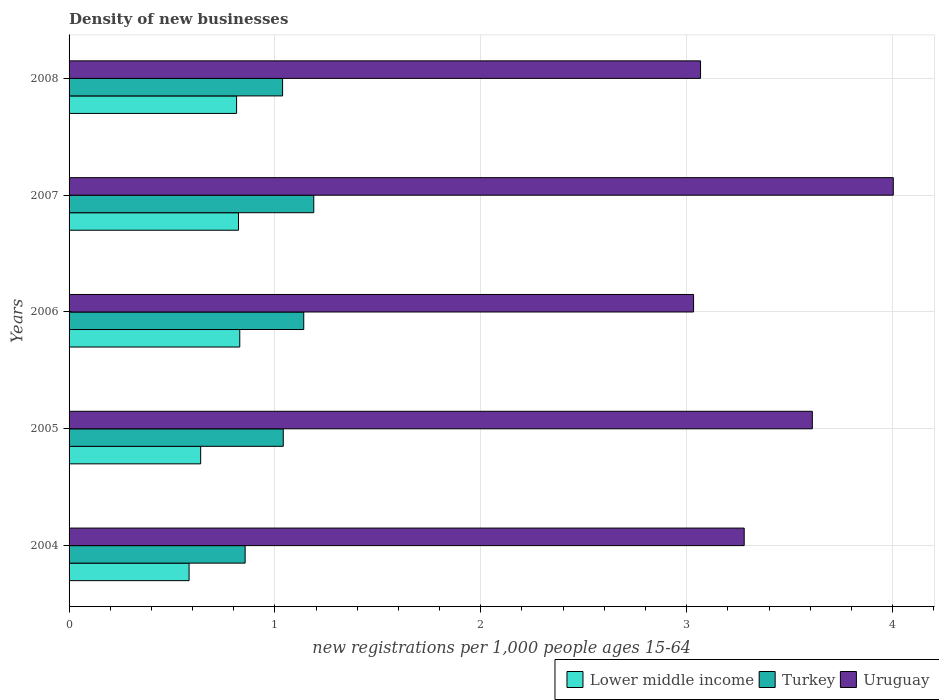How many groups of bars are there?
Your response must be concise. 5. Are the number of bars on each tick of the Y-axis equal?
Offer a very short reply. Yes. How many bars are there on the 4th tick from the top?
Ensure brevity in your answer.  3. What is the number of new registrations in Uruguay in 2004?
Provide a succinct answer. 3.28. Across all years, what is the maximum number of new registrations in Uruguay?
Give a very brief answer. 4. Across all years, what is the minimum number of new registrations in Lower middle income?
Make the answer very short. 0.58. In which year was the number of new registrations in Uruguay maximum?
Provide a short and direct response. 2007. In which year was the number of new registrations in Uruguay minimum?
Provide a succinct answer. 2006. What is the total number of new registrations in Turkey in the graph?
Make the answer very short. 5.26. What is the difference between the number of new registrations in Turkey in 2007 and that in 2008?
Make the answer very short. 0.15. What is the difference between the number of new registrations in Uruguay in 2008 and the number of new registrations in Lower middle income in 2007?
Provide a succinct answer. 2.24. What is the average number of new registrations in Uruguay per year?
Provide a succinct answer. 3.4. In the year 2007, what is the difference between the number of new registrations in Uruguay and number of new registrations in Turkey?
Make the answer very short. 2.82. What is the ratio of the number of new registrations in Lower middle income in 2004 to that in 2006?
Keep it short and to the point. 0.7. Is the number of new registrations in Uruguay in 2004 less than that in 2006?
Your answer should be very brief. No. What is the difference between the highest and the second highest number of new registrations in Uruguay?
Provide a short and direct response. 0.39. What is the difference between the highest and the lowest number of new registrations in Lower middle income?
Provide a succinct answer. 0.25. In how many years, is the number of new registrations in Uruguay greater than the average number of new registrations in Uruguay taken over all years?
Your answer should be very brief. 2. What does the 3rd bar from the bottom in 2004 represents?
Make the answer very short. Uruguay. How many bars are there?
Your answer should be compact. 15. Are all the bars in the graph horizontal?
Your response must be concise. Yes. How many years are there in the graph?
Your answer should be compact. 5. What is the difference between two consecutive major ticks on the X-axis?
Keep it short and to the point. 1. Does the graph contain any zero values?
Your response must be concise. No. How many legend labels are there?
Make the answer very short. 3. What is the title of the graph?
Provide a succinct answer. Density of new businesses. Does "Oman" appear as one of the legend labels in the graph?
Ensure brevity in your answer.  No. What is the label or title of the X-axis?
Make the answer very short. New registrations per 1,0 people ages 15-64. What is the label or title of the Y-axis?
Your answer should be compact. Years. What is the new registrations per 1,000 people ages 15-64 in Lower middle income in 2004?
Your answer should be compact. 0.58. What is the new registrations per 1,000 people ages 15-64 in Turkey in 2004?
Give a very brief answer. 0.86. What is the new registrations per 1,000 people ages 15-64 in Uruguay in 2004?
Keep it short and to the point. 3.28. What is the new registrations per 1,000 people ages 15-64 in Lower middle income in 2005?
Your answer should be very brief. 0.64. What is the new registrations per 1,000 people ages 15-64 in Turkey in 2005?
Provide a succinct answer. 1.04. What is the new registrations per 1,000 people ages 15-64 in Uruguay in 2005?
Your answer should be very brief. 3.61. What is the new registrations per 1,000 people ages 15-64 in Lower middle income in 2006?
Offer a terse response. 0.83. What is the new registrations per 1,000 people ages 15-64 in Turkey in 2006?
Provide a succinct answer. 1.14. What is the new registrations per 1,000 people ages 15-64 of Uruguay in 2006?
Your answer should be very brief. 3.03. What is the new registrations per 1,000 people ages 15-64 of Lower middle income in 2007?
Provide a short and direct response. 0.82. What is the new registrations per 1,000 people ages 15-64 in Turkey in 2007?
Your answer should be compact. 1.19. What is the new registrations per 1,000 people ages 15-64 of Uruguay in 2007?
Offer a very short reply. 4. What is the new registrations per 1,000 people ages 15-64 in Lower middle income in 2008?
Keep it short and to the point. 0.81. What is the new registrations per 1,000 people ages 15-64 of Turkey in 2008?
Provide a short and direct response. 1.04. What is the new registrations per 1,000 people ages 15-64 in Uruguay in 2008?
Ensure brevity in your answer.  3.07. Across all years, what is the maximum new registrations per 1,000 people ages 15-64 of Lower middle income?
Offer a very short reply. 0.83. Across all years, what is the maximum new registrations per 1,000 people ages 15-64 in Turkey?
Keep it short and to the point. 1.19. Across all years, what is the maximum new registrations per 1,000 people ages 15-64 in Uruguay?
Keep it short and to the point. 4. Across all years, what is the minimum new registrations per 1,000 people ages 15-64 of Lower middle income?
Your answer should be very brief. 0.58. Across all years, what is the minimum new registrations per 1,000 people ages 15-64 of Turkey?
Offer a terse response. 0.86. Across all years, what is the minimum new registrations per 1,000 people ages 15-64 in Uruguay?
Offer a terse response. 3.03. What is the total new registrations per 1,000 people ages 15-64 of Lower middle income in the graph?
Your answer should be compact. 3.69. What is the total new registrations per 1,000 people ages 15-64 in Turkey in the graph?
Ensure brevity in your answer.  5.26. What is the total new registrations per 1,000 people ages 15-64 in Uruguay in the graph?
Provide a succinct answer. 16.99. What is the difference between the new registrations per 1,000 people ages 15-64 of Lower middle income in 2004 and that in 2005?
Your response must be concise. -0.06. What is the difference between the new registrations per 1,000 people ages 15-64 of Turkey in 2004 and that in 2005?
Keep it short and to the point. -0.19. What is the difference between the new registrations per 1,000 people ages 15-64 in Uruguay in 2004 and that in 2005?
Your response must be concise. -0.33. What is the difference between the new registrations per 1,000 people ages 15-64 in Lower middle income in 2004 and that in 2006?
Offer a very short reply. -0.25. What is the difference between the new registrations per 1,000 people ages 15-64 in Turkey in 2004 and that in 2006?
Make the answer very short. -0.28. What is the difference between the new registrations per 1,000 people ages 15-64 of Uruguay in 2004 and that in 2006?
Make the answer very short. 0.25. What is the difference between the new registrations per 1,000 people ages 15-64 of Lower middle income in 2004 and that in 2007?
Offer a terse response. -0.24. What is the difference between the new registrations per 1,000 people ages 15-64 in Turkey in 2004 and that in 2007?
Provide a succinct answer. -0.33. What is the difference between the new registrations per 1,000 people ages 15-64 of Uruguay in 2004 and that in 2007?
Ensure brevity in your answer.  -0.72. What is the difference between the new registrations per 1,000 people ages 15-64 of Lower middle income in 2004 and that in 2008?
Provide a succinct answer. -0.23. What is the difference between the new registrations per 1,000 people ages 15-64 in Turkey in 2004 and that in 2008?
Offer a very short reply. -0.18. What is the difference between the new registrations per 1,000 people ages 15-64 in Uruguay in 2004 and that in 2008?
Your answer should be very brief. 0.21. What is the difference between the new registrations per 1,000 people ages 15-64 of Lower middle income in 2005 and that in 2006?
Provide a short and direct response. -0.19. What is the difference between the new registrations per 1,000 people ages 15-64 of Turkey in 2005 and that in 2006?
Provide a succinct answer. -0.1. What is the difference between the new registrations per 1,000 people ages 15-64 in Uruguay in 2005 and that in 2006?
Offer a terse response. 0.58. What is the difference between the new registrations per 1,000 people ages 15-64 of Lower middle income in 2005 and that in 2007?
Your answer should be compact. -0.18. What is the difference between the new registrations per 1,000 people ages 15-64 of Turkey in 2005 and that in 2007?
Give a very brief answer. -0.15. What is the difference between the new registrations per 1,000 people ages 15-64 of Uruguay in 2005 and that in 2007?
Your answer should be compact. -0.39. What is the difference between the new registrations per 1,000 people ages 15-64 in Lower middle income in 2005 and that in 2008?
Your response must be concise. -0.17. What is the difference between the new registrations per 1,000 people ages 15-64 of Turkey in 2005 and that in 2008?
Provide a short and direct response. 0. What is the difference between the new registrations per 1,000 people ages 15-64 in Uruguay in 2005 and that in 2008?
Your answer should be very brief. 0.54. What is the difference between the new registrations per 1,000 people ages 15-64 of Lower middle income in 2006 and that in 2007?
Provide a short and direct response. 0.01. What is the difference between the new registrations per 1,000 people ages 15-64 of Turkey in 2006 and that in 2007?
Provide a short and direct response. -0.05. What is the difference between the new registrations per 1,000 people ages 15-64 of Uruguay in 2006 and that in 2007?
Provide a short and direct response. -0.97. What is the difference between the new registrations per 1,000 people ages 15-64 of Lower middle income in 2006 and that in 2008?
Your answer should be compact. 0.02. What is the difference between the new registrations per 1,000 people ages 15-64 of Turkey in 2006 and that in 2008?
Your response must be concise. 0.1. What is the difference between the new registrations per 1,000 people ages 15-64 in Uruguay in 2006 and that in 2008?
Make the answer very short. -0.03. What is the difference between the new registrations per 1,000 people ages 15-64 of Lower middle income in 2007 and that in 2008?
Give a very brief answer. 0.01. What is the difference between the new registrations per 1,000 people ages 15-64 in Turkey in 2007 and that in 2008?
Your answer should be compact. 0.15. What is the difference between the new registrations per 1,000 people ages 15-64 in Uruguay in 2007 and that in 2008?
Offer a very short reply. 0.94. What is the difference between the new registrations per 1,000 people ages 15-64 of Lower middle income in 2004 and the new registrations per 1,000 people ages 15-64 of Turkey in 2005?
Provide a short and direct response. -0.46. What is the difference between the new registrations per 1,000 people ages 15-64 of Lower middle income in 2004 and the new registrations per 1,000 people ages 15-64 of Uruguay in 2005?
Make the answer very short. -3.03. What is the difference between the new registrations per 1,000 people ages 15-64 in Turkey in 2004 and the new registrations per 1,000 people ages 15-64 in Uruguay in 2005?
Provide a succinct answer. -2.76. What is the difference between the new registrations per 1,000 people ages 15-64 of Lower middle income in 2004 and the new registrations per 1,000 people ages 15-64 of Turkey in 2006?
Your response must be concise. -0.56. What is the difference between the new registrations per 1,000 people ages 15-64 of Lower middle income in 2004 and the new registrations per 1,000 people ages 15-64 of Uruguay in 2006?
Provide a short and direct response. -2.45. What is the difference between the new registrations per 1,000 people ages 15-64 in Turkey in 2004 and the new registrations per 1,000 people ages 15-64 in Uruguay in 2006?
Provide a succinct answer. -2.18. What is the difference between the new registrations per 1,000 people ages 15-64 of Lower middle income in 2004 and the new registrations per 1,000 people ages 15-64 of Turkey in 2007?
Keep it short and to the point. -0.61. What is the difference between the new registrations per 1,000 people ages 15-64 in Lower middle income in 2004 and the new registrations per 1,000 people ages 15-64 in Uruguay in 2007?
Give a very brief answer. -3.42. What is the difference between the new registrations per 1,000 people ages 15-64 of Turkey in 2004 and the new registrations per 1,000 people ages 15-64 of Uruguay in 2007?
Your answer should be compact. -3.15. What is the difference between the new registrations per 1,000 people ages 15-64 of Lower middle income in 2004 and the new registrations per 1,000 people ages 15-64 of Turkey in 2008?
Your answer should be compact. -0.45. What is the difference between the new registrations per 1,000 people ages 15-64 of Lower middle income in 2004 and the new registrations per 1,000 people ages 15-64 of Uruguay in 2008?
Make the answer very short. -2.48. What is the difference between the new registrations per 1,000 people ages 15-64 in Turkey in 2004 and the new registrations per 1,000 people ages 15-64 in Uruguay in 2008?
Give a very brief answer. -2.21. What is the difference between the new registrations per 1,000 people ages 15-64 in Lower middle income in 2005 and the new registrations per 1,000 people ages 15-64 in Turkey in 2006?
Make the answer very short. -0.5. What is the difference between the new registrations per 1,000 people ages 15-64 in Lower middle income in 2005 and the new registrations per 1,000 people ages 15-64 in Uruguay in 2006?
Your answer should be compact. -2.39. What is the difference between the new registrations per 1,000 people ages 15-64 in Turkey in 2005 and the new registrations per 1,000 people ages 15-64 in Uruguay in 2006?
Ensure brevity in your answer.  -1.99. What is the difference between the new registrations per 1,000 people ages 15-64 in Lower middle income in 2005 and the new registrations per 1,000 people ages 15-64 in Turkey in 2007?
Keep it short and to the point. -0.55. What is the difference between the new registrations per 1,000 people ages 15-64 of Lower middle income in 2005 and the new registrations per 1,000 people ages 15-64 of Uruguay in 2007?
Give a very brief answer. -3.36. What is the difference between the new registrations per 1,000 people ages 15-64 in Turkey in 2005 and the new registrations per 1,000 people ages 15-64 in Uruguay in 2007?
Offer a very short reply. -2.96. What is the difference between the new registrations per 1,000 people ages 15-64 of Lower middle income in 2005 and the new registrations per 1,000 people ages 15-64 of Turkey in 2008?
Give a very brief answer. -0.4. What is the difference between the new registrations per 1,000 people ages 15-64 in Lower middle income in 2005 and the new registrations per 1,000 people ages 15-64 in Uruguay in 2008?
Make the answer very short. -2.43. What is the difference between the new registrations per 1,000 people ages 15-64 in Turkey in 2005 and the new registrations per 1,000 people ages 15-64 in Uruguay in 2008?
Provide a short and direct response. -2.03. What is the difference between the new registrations per 1,000 people ages 15-64 of Lower middle income in 2006 and the new registrations per 1,000 people ages 15-64 of Turkey in 2007?
Keep it short and to the point. -0.36. What is the difference between the new registrations per 1,000 people ages 15-64 of Lower middle income in 2006 and the new registrations per 1,000 people ages 15-64 of Uruguay in 2007?
Keep it short and to the point. -3.17. What is the difference between the new registrations per 1,000 people ages 15-64 in Turkey in 2006 and the new registrations per 1,000 people ages 15-64 in Uruguay in 2007?
Offer a terse response. -2.86. What is the difference between the new registrations per 1,000 people ages 15-64 in Lower middle income in 2006 and the new registrations per 1,000 people ages 15-64 in Turkey in 2008?
Offer a very short reply. -0.21. What is the difference between the new registrations per 1,000 people ages 15-64 in Lower middle income in 2006 and the new registrations per 1,000 people ages 15-64 in Uruguay in 2008?
Ensure brevity in your answer.  -2.24. What is the difference between the new registrations per 1,000 people ages 15-64 in Turkey in 2006 and the new registrations per 1,000 people ages 15-64 in Uruguay in 2008?
Provide a short and direct response. -1.93. What is the difference between the new registrations per 1,000 people ages 15-64 of Lower middle income in 2007 and the new registrations per 1,000 people ages 15-64 of Turkey in 2008?
Your answer should be very brief. -0.21. What is the difference between the new registrations per 1,000 people ages 15-64 of Lower middle income in 2007 and the new registrations per 1,000 people ages 15-64 of Uruguay in 2008?
Provide a short and direct response. -2.24. What is the difference between the new registrations per 1,000 people ages 15-64 of Turkey in 2007 and the new registrations per 1,000 people ages 15-64 of Uruguay in 2008?
Keep it short and to the point. -1.88. What is the average new registrations per 1,000 people ages 15-64 of Lower middle income per year?
Ensure brevity in your answer.  0.74. What is the average new registrations per 1,000 people ages 15-64 of Turkey per year?
Your response must be concise. 1.05. What is the average new registrations per 1,000 people ages 15-64 of Uruguay per year?
Your response must be concise. 3.4. In the year 2004, what is the difference between the new registrations per 1,000 people ages 15-64 of Lower middle income and new registrations per 1,000 people ages 15-64 of Turkey?
Provide a succinct answer. -0.27. In the year 2004, what is the difference between the new registrations per 1,000 people ages 15-64 of Lower middle income and new registrations per 1,000 people ages 15-64 of Uruguay?
Provide a short and direct response. -2.7. In the year 2004, what is the difference between the new registrations per 1,000 people ages 15-64 of Turkey and new registrations per 1,000 people ages 15-64 of Uruguay?
Offer a very short reply. -2.42. In the year 2005, what is the difference between the new registrations per 1,000 people ages 15-64 in Lower middle income and new registrations per 1,000 people ages 15-64 in Turkey?
Provide a short and direct response. -0.4. In the year 2005, what is the difference between the new registrations per 1,000 people ages 15-64 in Lower middle income and new registrations per 1,000 people ages 15-64 in Uruguay?
Provide a short and direct response. -2.97. In the year 2005, what is the difference between the new registrations per 1,000 people ages 15-64 of Turkey and new registrations per 1,000 people ages 15-64 of Uruguay?
Your answer should be compact. -2.57. In the year 2006, what is the difference between the new registrations per 1,000 people ages 15-64 in Lower middle income and new registrations per 1,000 people ages 15-64 in Turkey?
Offer a very short reply. -0.31. In the year 2006, what is the difference between the new registrations per 1,000 people ages 15-64 in Lower middle income and new registrations per 1,000 people ages 15-64 in Uruguay?
Your answer should be very brief. -2.2. In the year 2006, what is the difference between the new registrations per 1,000 people ages 15-64 of Turkey and new registrations per 1,000 people ages 15-64 of Uruguay?
Provide a succinct answer. -1.89. In the year 2007, what is the difference between the new registrations per 1,000 people ages 15-64 in Lower middle income and new registrations per 1,000 people ages 15-64 in Turkey?
Offer a very short reply. -0.37. In the year 2007, what is the difference between the new registrations per 1,000 people ages 15-64 of Lower middle income and new registrations per 1,000 people ages 15-64 of Uruguay?
Your answer should be very brief. -3.18. In the year 2007, what is the difference between the new registrations per 1,000 people ages 15-64 of Turkey and new registrations per 1,000 people ages 15-64 of Uruguay?
Offer a very short reply. -2.81. In the year 2008, what is the difference between the new registrations per 1,000 people ages 15-64 in Lower middle income and new registrations per 1,000 people ages 15-64 in Turkey?
Provide a succinct answer. -0.22. In the year 2008, what is the difference between the new registrations per 1,000 people ages 15-64 of Lower middle income and new registrations per 1,000 people ages 15-64 of Uruguay?
Offer a terse response. -2.25. In the year 2008, what is the difference between the new registrations per 1,000 people ages 15-64 in Turkey and new registrations per 1,000 people ages 15-64 in Uruguay?
Give a very brief answer. -2.03. What is the ratio of the new registrations per 1,000 people ages 15-64 in Lower middle income in 2004 to that in 2005?
Offer a terse response. 0.91. What is the ratio of the new registrations per 1,000 people ages 15-64 in Turkey in 2004 to that in 2005?
Provide a short and direct response. 0.82. What is the ratio of the new registrations per 1,000 people ages 15-64 in Uruguay in 2004 to that in 2005?
Ensure brevity in your answer.  0.91. What is the ratio of the new registrations per 1,000 people ages 15-64 in Lower middle income in 2004 to that in 2006?
Offer a terse response. 0.7. What is the ratio of the new registrations per 1,000 people ages 15-64 of Turkey in 2004 to that in 2006?
Keep it short and to the point. 0.75. What is the ratio of the new registrations per 1,000 people ages 15-64 of Uruguay in 2004 to that in 2006?
Offer a terse response. 1.08. What is the ratio of the new registrations per 1,000 people ages 15-64 of Lower middle income in 2004 to that in 2007?
Provide a short and direct response. 0.71. What is the ratio of the new registrations per 1,000 people ages 15-64 in Turkey in 2004 to that in 2007?
Provide a short and direct response. 0.72. What is the ratio of the new registrations per 1,000 people ages 15-64 of Uruguay in 2004 to that in 2007?
Provide a succinct answer. 0.82. What is the ratio of the new registrations per 1,000 people ages 15-64 in Lower middle income in 2004 to that in 2008?
Ensure brevity in your answer.  0.72. What is the ratio of the new registrations per 1,000 people ages 15-64 in Turkey in 2004 to that in 2008?
Offer a very short reply. 0.82. What is the ratio of the new registrations per 1,000 people ages 15-64 in Uruguay in 2004 to that in 2008?
Your answer should be compact. 1.07. What is the ratio of the new registrations per 1,000 people ages 15-64 of Lower middle income in 2005 to that in 2006?
Provide a short and direct response. 0.77. What is the ratio of the new registrations per 1,000 people ages 15-64 in Turkey in 2005 to that in 2006?
Give a very brief answer. 0.91. What is the ratio of the new registrations per 1,000 people ages 15-64 of Uruguay in 2005 to that in 2006?
Your answer should be very brief. 1.19. What is the ratio of the new registrations per 1,000 people ages 15-64 in Lower middle income in 2005 to that in 2007?
Your response must be concise. 0.78. What is the ratio of the new registrations per 1,000 people ages 15-64 in Turkey in 2005 to that in 2007?
Provide a succinct answer. 0.88. What is the ratio of the new registrations per 1,000 people ages 15-64 of Uruguay in 2005 to that in 2007?
Keep it short and to the point. 0.9. What is the ratio of the new registrations per 1,000 people ages 15-64 of Lower middle income in 2005 to that in 2008?
Ensure brevity in your answer.  0.79. What is the ratio of the new registrations per 1,000 people ages 15-64 of Uruguay in 2005 to that in 2008?
Provide a succinct answer. 1.18. What is the ratio of the new registrations per 1,000 people ages 15-64 in Lower middle income in 2006 to that in 2007?
Your answer should be very brief. 1.01. What is the ratio of the new registrations per 1,000 people ages 15-64 in Turkey in 2006 to that in 2007?
Offer a very short reply. 0.96. What is the ratio of the new registrations per 1,000 people ages 15-64 of Uruguay in 2006 to that in 2007?
Offer a very short reply. 0.76. What is the ratio of the new registrations per 1,000 people ages 15-64 in Lower middle income in 2006 to that in 2008?
Make the answer very short. 1.02. What is the ratio of the new registrations per 1,000 people ages 15-64 of Turkey in 2006 to that in 2008?
Your answer should be very brief. 1.1. What is the ratio of the new registrations per 1,000 people ages 15-64 in Uruguay in 2006 to that in 2008?
Keep it short and to the point. 0.99. What is the ratio of the new registrations per 1,000 people ages 15-64 of Lower middle income in 2007 to that in 2008?
Your answer should be compact. 1.01. What is the ratio of the new registrations per 1,000 people ages 15-64 in Turkey in 2007 to that in 2008?
Provide a succinct answer. 1.15. What is the ratio of the new registrations per 1,000 people ages 15-64 in Uruguay in 2007 to that in 2008?
Your answer should be compact. 1.31. What is the difference between the highest and the second highest new registrations per 1,000 people ages 15-64 of Lower middle income?
Ensure brevity in your answer.  0.01. What is the difference between the highest and the second highest new registrations per 1,000 people ages 15-64 of Turkey?
Your answer should be compact. 0.05. What is the difference between the highest and the second highest new registrations per 1,000 people ages 15-64 of Uruguay?
Keep it short and to the point. 0.39. What is the difference between the highest and the lowest new registrations per 1,000 people ages 15-64 in Lower middle income?
Ensure brevity in your answer.  0.25. What is the difference between the highest and the lowest new registrations per 1,000 people ages 15-64 in Turkey?
Give a very brief answer. 0.33. What is the difference between the highest and the lowest new registrations per 1,000 people ages 15-64 in Uruguay?
Keep it short and to the point. 0.97. 